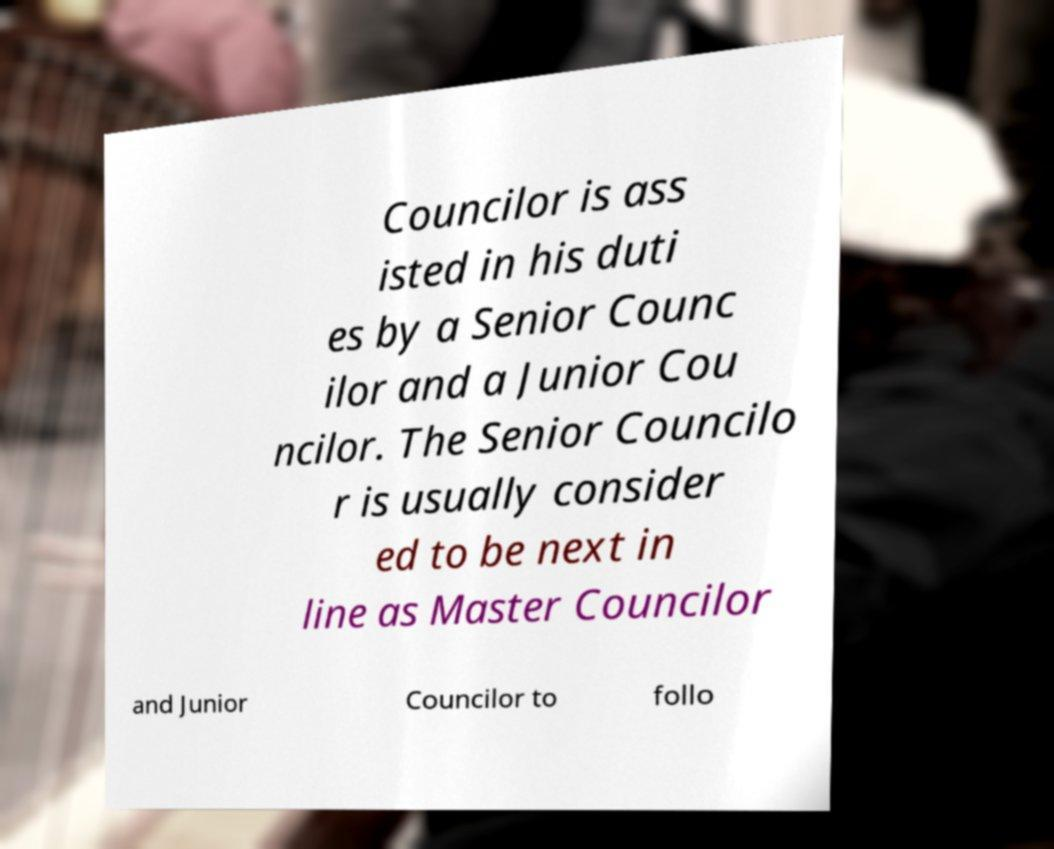Could you extract and type out the text from this image? Councilor is ass isted in his duti es by a Senior Counc ilor and a Junior Cou ncilor. The Senior Councilo r is usually consider ed to be next in line as Master Councilor and Junior Councilor to follo 